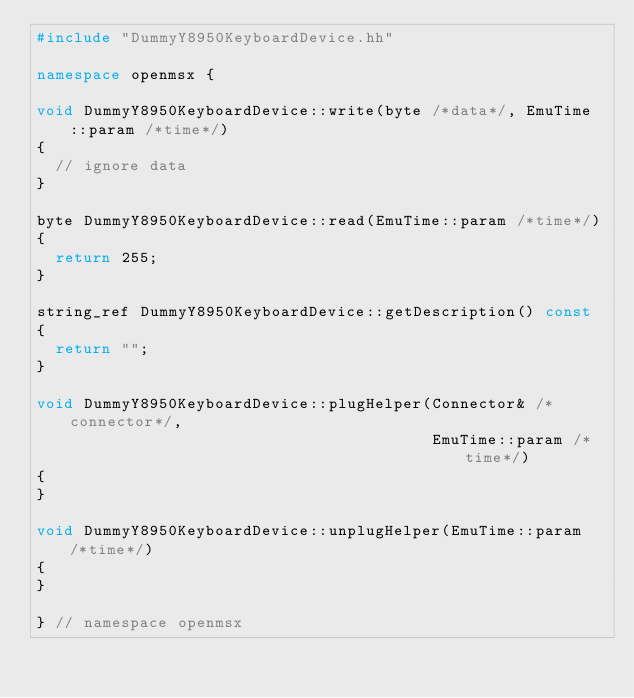<code> <loc_0><loc_0><loc_500><loc_500><_C++_>#include "DummyY8950KeyboardDevice.hh"

namespace openmsx {

void DummyY8950KeyboardDevice::write(byte /*data*/, EmuTime::param /*time*/)
{
	// ignore data
}

byte DummyY8950KeyboardDevice::read(EmuTime::param /*time*/)
{
	return 255;
}

string_ref DummyY8950KeyboardDevice::getDescription() const
{
	return "";
}

void DummyY8950KeyboardDevice::plugHelper(Connector& /*connector*/,
                                          EmuTime::param /*time*/)
{
}

void DummyY8950KeyboardDevice::unplugHelper(EmuTime::param /*time*/)
{
}

} // namespace openmsx
</code> 